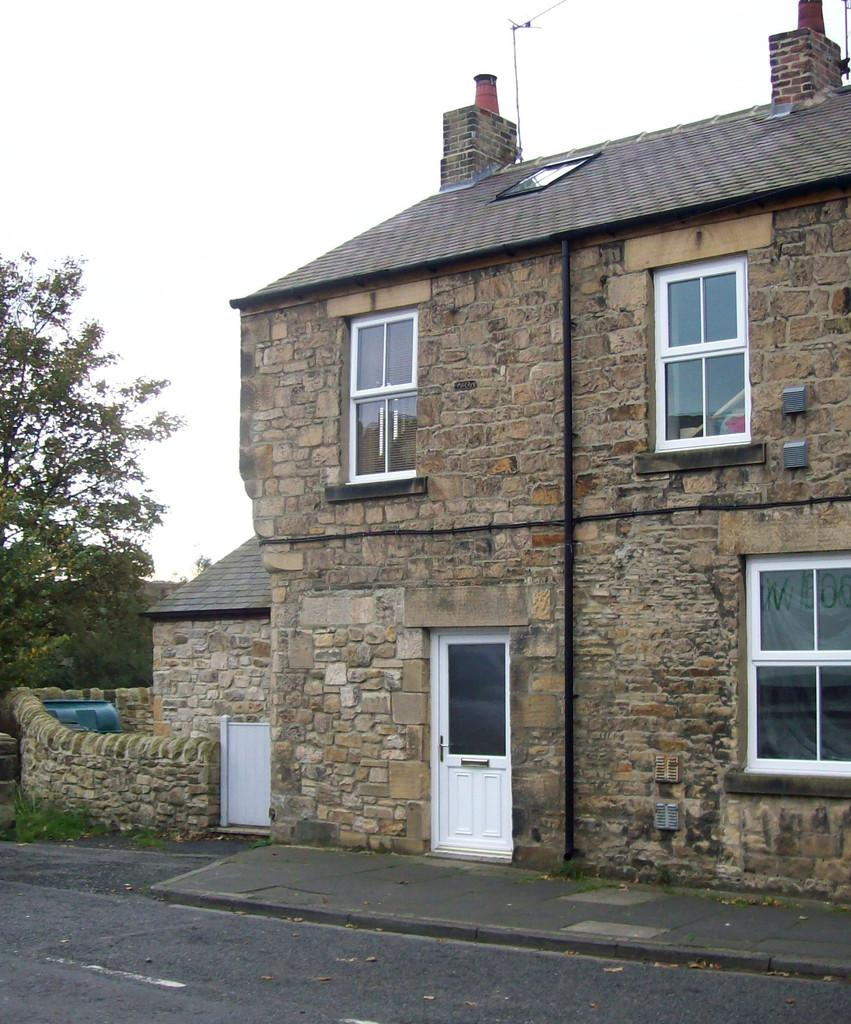What type of structure is in the image? There is a building in the image. What is the color of the door on the building? The building has a white door. What other features can be seen on the building? The building has windows. What is located on the left side of the image? There is a tree on the left side of the image. What is visible at the top of the image? The sky is visible at the top of the image. What type of fruit is being used to paint the building in the image? There is no fruit present in the image, and the building is not being painted. 